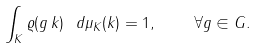<formula> <loc_0><loc_0><loc_500><loc_500>\int _ { K } \varrho ( g \, k ) \ d \mu _ { K } ( k ) = 1 , \quad \forall g \in G .</formula> 